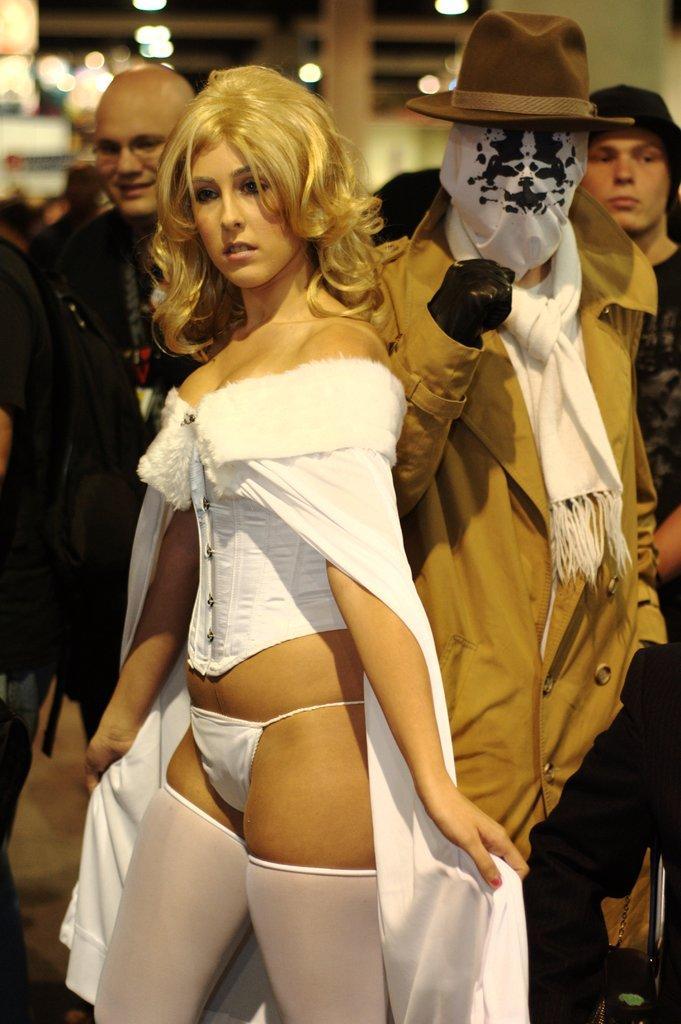What is the main subject of the image? The main subject of the image is a group of people. What are the people in the image doing? The people are standing. Can you describe the background of the image? There are blurred objects in the background of the image. What type of apple is being judged by the group of people in the image? There is no apple or judging activity present in the image; it features a group of people standing. 